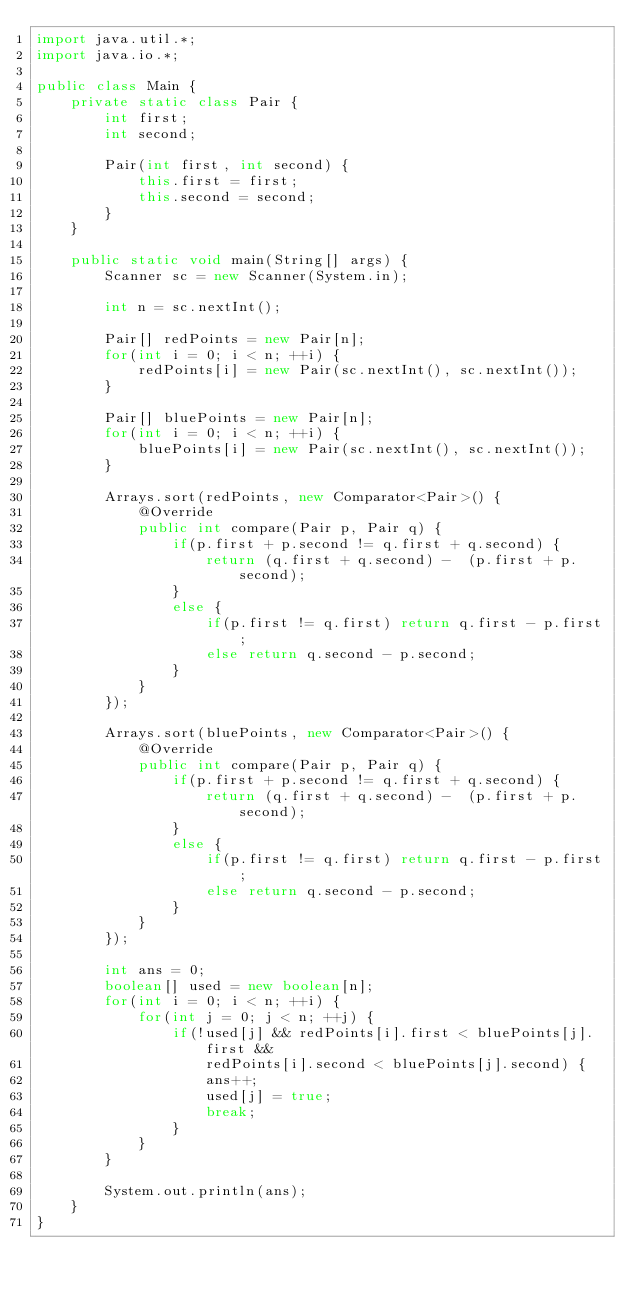<code> <loc_0><loc_0><loc_500><loc_500><_Java_>import java.util.*;
import java.io.*;

public class Main {
	private static class Pair {
		int first;
		int second;

		Pair(int first, int second) {
			this.first = first;
			this.second = second;
		}
	}

	public static void main(String[] args) {
		Scanner sc = new Scanner(System.in);

		int n = sc.nextInt();

		Pair[] redPoints = new Pair[n];
		for(int i = 0; i < n; ++i) {
			redPoints[i] = new Pair(sc.nextInt(), sc.nextInt());
		}

		Pair[] bluePoints = new Pair[n];
		for(int i = 0; i < n; ++i) {
			bluePoints[i] = new Pair(sc.nextInt(), sc.nextInt());
		}

		Arrays.sort(redPoints, new Comparator<Pair>() {
			@Override
			public int compare(Pair p, Pair q) {
				if(p.first + p.second != q.first + q.second) {
					return (q.first + q.second) -  (p.first + p.second);
				}
				else {
					if(p.first != q.first) return q.first - p.first;
					else return q.second - p.second;
				}
			}
		});

		Arrays.sort(bluePoints, new Comparator<Pair>() {
			@Override
			public int compare(Pair p, Pair q) {
				if(p.first + p.second != q.first + q.second) {
					return (q.first + q.second) -  (p.first + p.second);
				}
				else {
					if(p.first != q.first) return q.first - p.first;
					else return q.second - p.second;
				}
			}
		});

		int ans = 0;
		boolean[] used = new boolean[n];
		for(int i = 0; i < n; ++i) {
			for(int j = 0; j < n; ++j) {
				if(!used[j] && redPoints[i].first < bluePoints[j].first &&
					redPoints[i].second < bluePoints[j].second) {
					ans++;
					used[j] = true;
					break;
				}
			}
		}

		System.out.println(ans);
	}
}</code> 